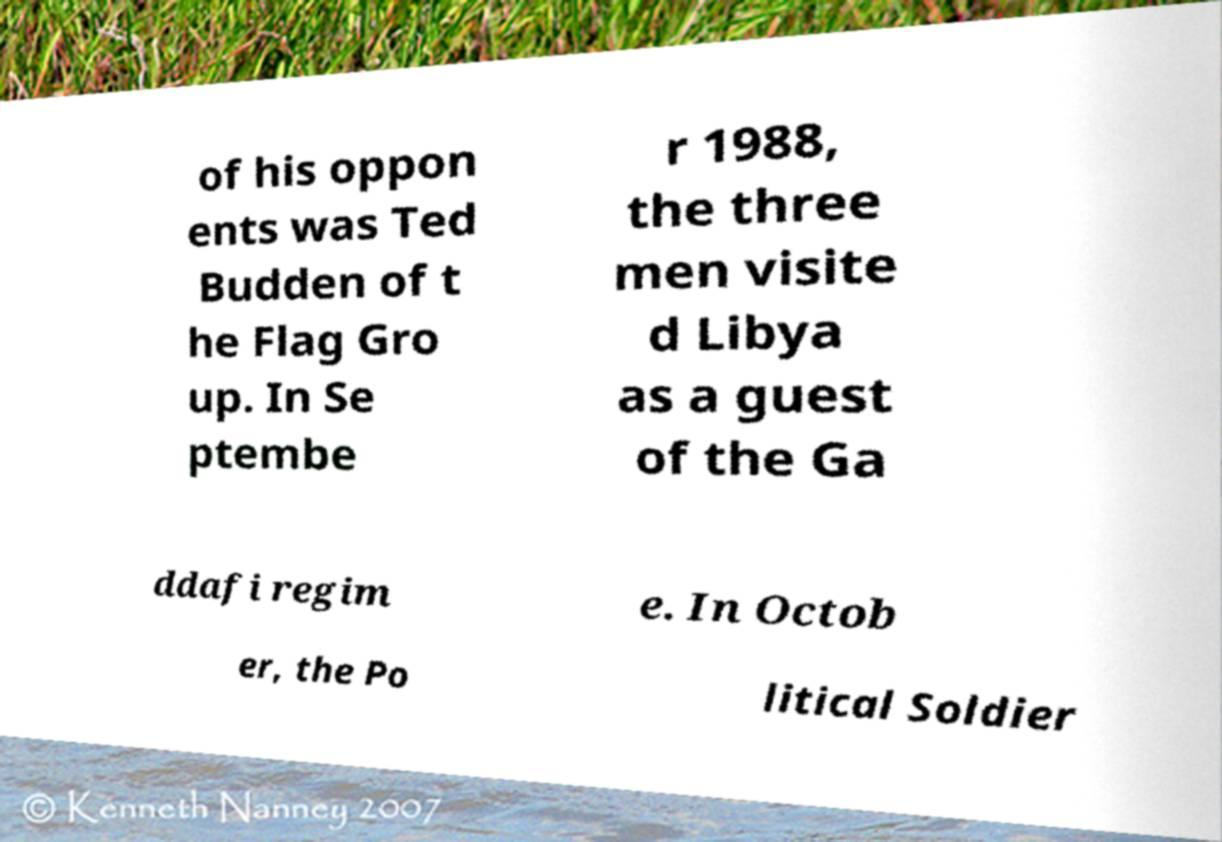I need the written content from this picture converted into text. Can you do that? of his oppon ents was Ted Budden of t he Flag Gro up. In Se ptembe r 1988, the three men visite d Libya as a guest of the Ga ddafi regim e. In Octob er, the Po litical Soldier 